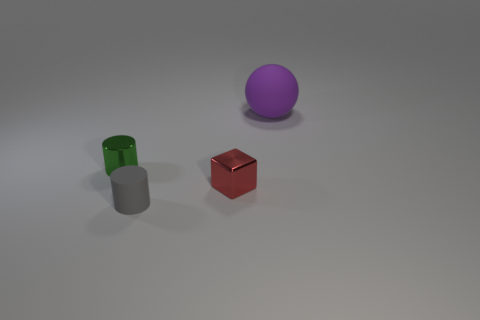Add 1 tiny yellow metallic objects. How many objects exist? 5 Add 3 big gray metal things. How many big gray metal things exist? 3 Subtract 0 blue blocks. How many objects are left? 4 Subtract all small purple shiny things. Subtract all small green cylinders. How many objects are left? 3 Add 3 small red blocks. How many small red blocks are left? 4 